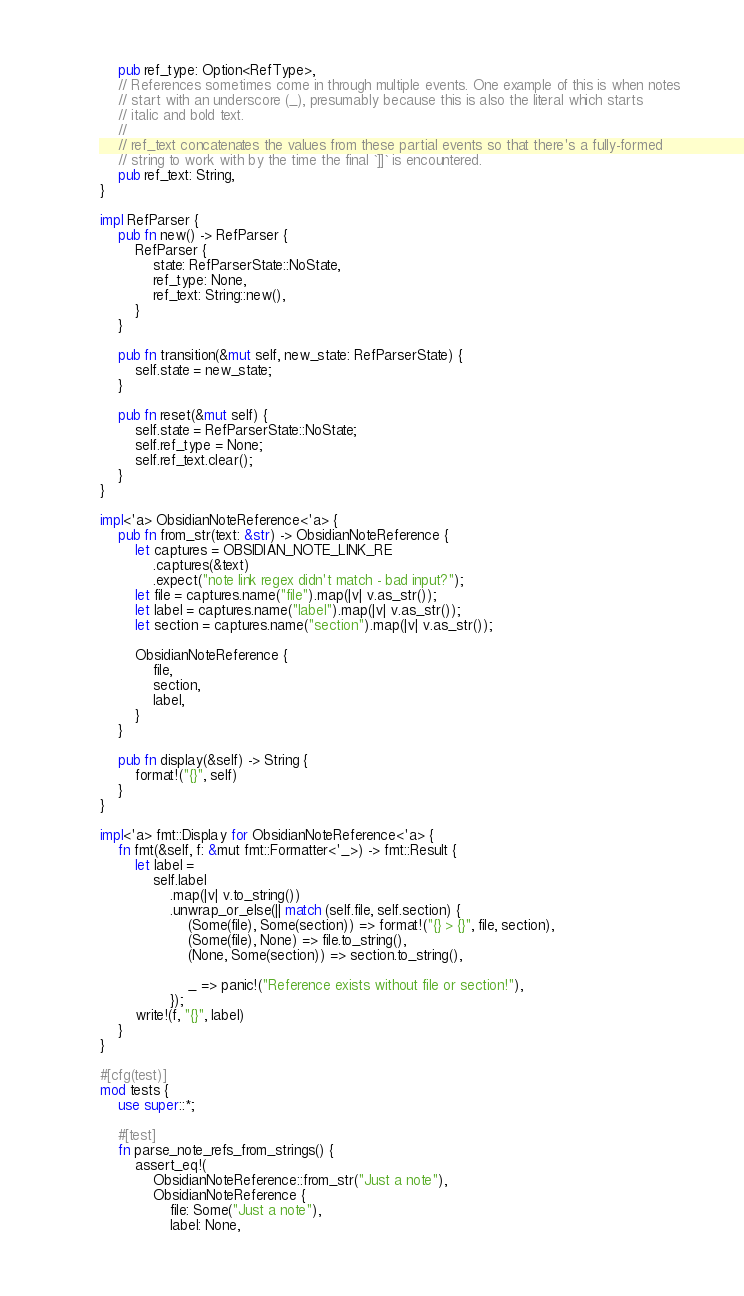<code> <loc_0><loc_0><loc_500><loc_500><_Rust_>    pub ref_type: Option<RefType>,
    // References sometimes come in through multiple events. One example of this is when notes
    // start with an underscore (_), presumably because this is also the literal which starts
    // italic and bold text.
    //
    // ref_text concatenates the values from these partial events so that there's a fully-formed
    // string to work with by the time the final `]]` is encountered.
    pub ref_text: String,
}

impl RefParser {
    pub fn new() -> RefParser {
        RefParser {
            state: RefParserState::NoState,
            ref_type: None,
            ref_text: String::new(),
        }
    }

    pub fn transition(&mut self, new_state: RefParserState) {
        self.state = new_state;
    }

    pub fn reset(&mut self) {
        self.state = RefParserState::NoState;
        self.ref_type = None;
        self.ref_text.clear();
    }
}

impl<'a> ObsidianNoteReference<'a> {
    pub fn from_str(text: &str) -> ObsidianNoteReference {
        let captures = OBSIDIAN_NOTE_LINK_RE
            .captures(&text)
            .expect("note link regex didn't match - bad input?");
        let file = captures.name("file").map(|v| v.as_str());
        let label = captures.name("label").map(|v| v.as_str());
        let section = captures.name("section").map(|v| v.as_str());

        ObsidianNoteReference {
            file,
            section,
            label,
        }
    }

    pub fn display(&self) -> String {
        format!("{}", self)
    }
}

impl<'a> fmt::Display for ObsidianNoteReference<'a> {
    fn fmt(&self, f: &mut fmt::Formatter<'_>) -> fmt::Result {
        let label =
            self.label
                .map(|v| v.to_string())
                .unwrap_or_else(|| match (self.file, self.section) {
                    (Some(file), Some(section)) => format!("{} > {}", file, section),
                    (Some(file), None) => file.to_string(),
                    (None, Some(section)) => section.to_string(),

                    _ => panic!("Reference exists without file or section!"),
                });
        write!(f, "{}", label)
    }
}

#[cfg(test)]
mod tests {
    use super::*;

    #[test]
    fn parse_note_refs_from_strings() {
        assert_eq!(
            ObsidianNoteReference::from_str("Just a note"),
            ObsidianNoteReference {
                file: Some("Just a note"),
                label: None,</code> 